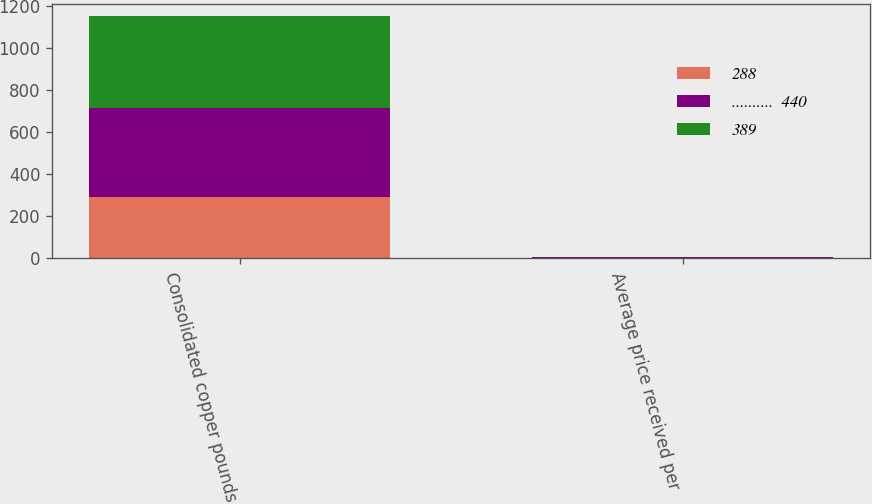Convert chart to OTSL. <chart><loc_0><loc_0><loc_500><loc_500><stacked_bar_chart><ecel><fcel>Consolidated copper pounds<fcel>Average price received per<nl><fcel>288<fcel>290<fcel>2.59<nl><fcel>..........  440<fcel>428<fcel>2.86<nl><fcel>389<fcel>435<fcel>1.54<nl></chart> 